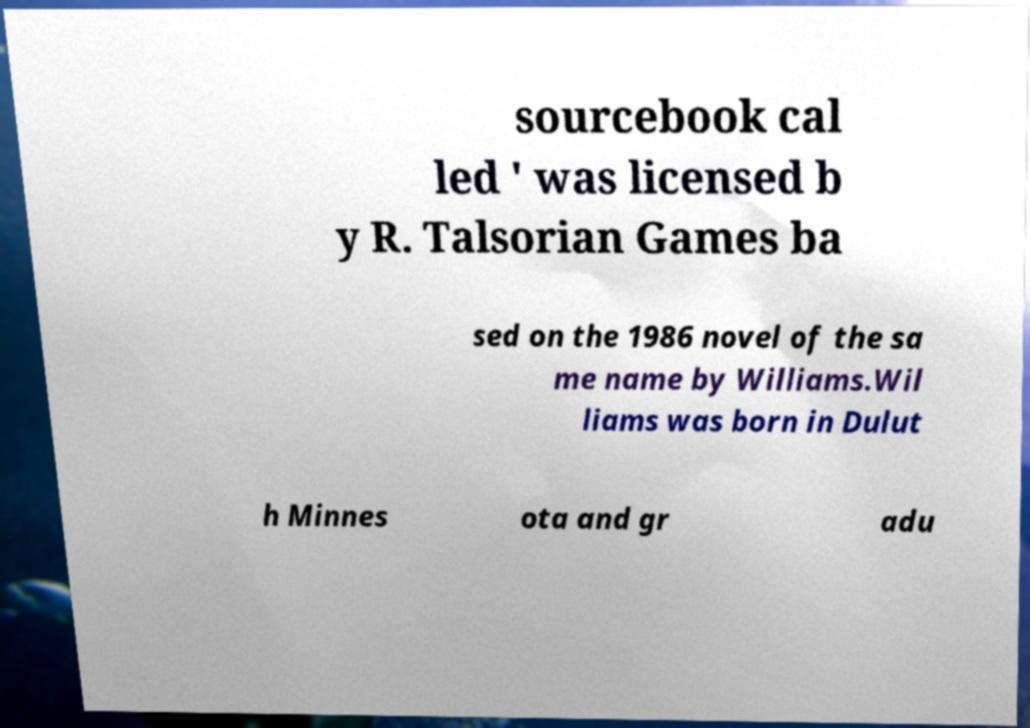There's text embedded in this image that I need extracted. Can you transcribe it verbatim? sourcebook cal led ' was licensed b y R. Talsorian Games ba sed on the 1986 novel of the sa me name by Williams.Wil liams was born in Dulut h Minnes ota and gr adu 